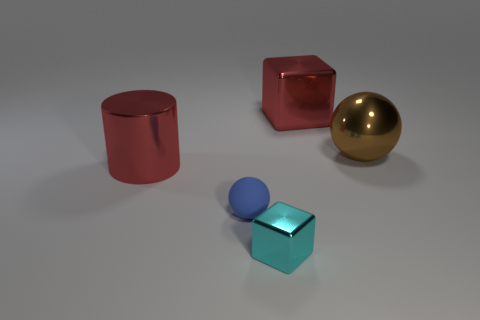How many other things are there of the same material as the tiny ball? Judging by the image, the tiny blue ball appears to be made of a matte material which differs from the glossy materials of the larger shapes. Therefore, there are no other objects made of the exact same material as the tiny ball. 